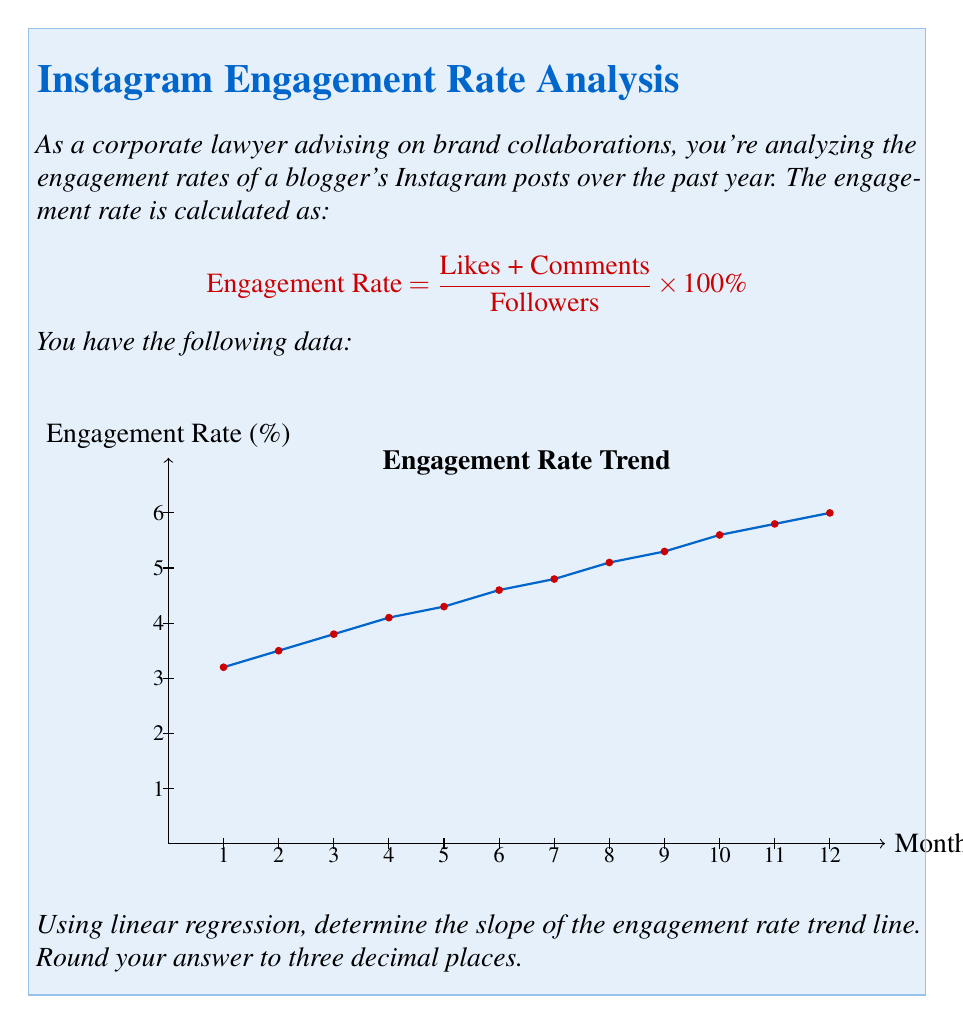Provide a solution to this math problem. To find the slope of the trend line using linear regression, we'll use the formula:

$$ m = \frac{n\sum xy - \sum x \sum y}{n\sum x^2 - (\sum x)^2} $$

Where:
$m$ is the slope
$n$ is the number of data points
$x$ represents the months
$y$ represents the engagement rates

Step 1: Calculate the required sums:
$n = 12$
$\sum x = 1 + 2 + 3 + ... + 12 = 78$
$\sum y = 3.2 + 3.5 + 3.8 + ... + 6.0 = 56.1$
$\sum xy = (1 \times 3.2) + (2 \times 3.5) + ... + (12 \times 6.0) = 454.5$
$\sum x^2 = 1^2 + 2^2 + ... + 12^2 = 650$

Step 2: Plug these values into the slope formula:

$$ m = \frac{12(454.5) - 78(56.1)}{12(650) - 78^2} $$

Step 3: Solve the equation:

$$ m = \frac{5454 - 4375.8}{7800 - 6084} = \frac{1078.2}{1716} \approx 0.628 $$

Step 4: Round to three decimal places: 0.628
Answer: 0.628 